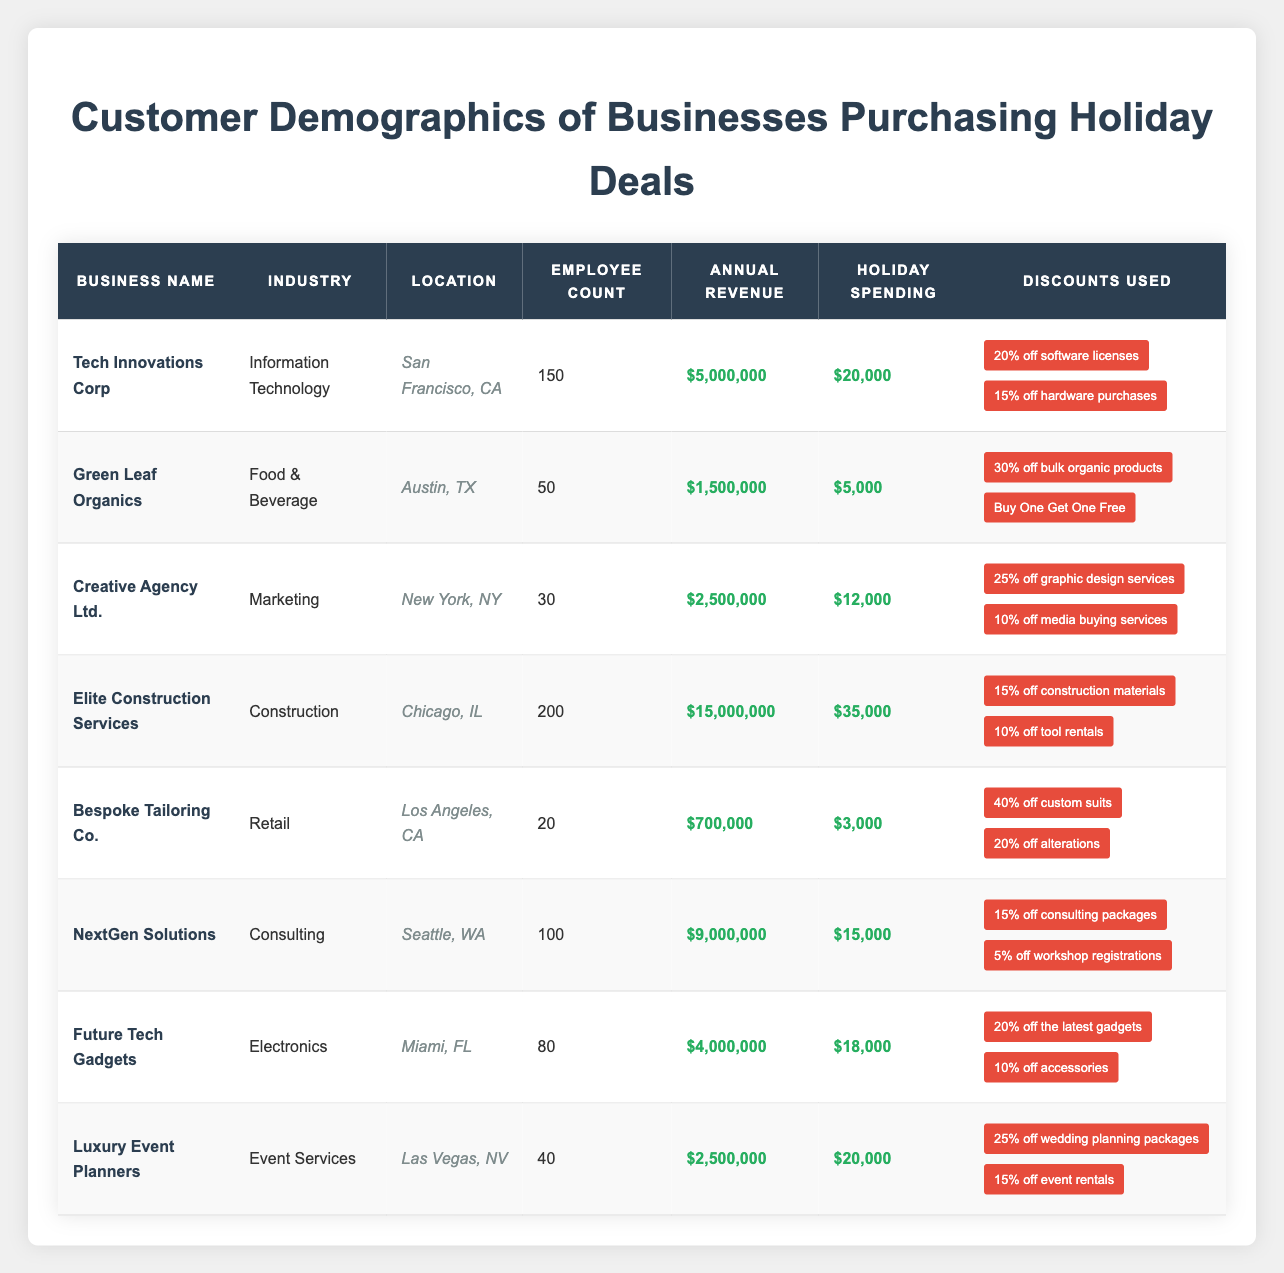What is the business with the highest holiday spending? Looking through the holiday spending amounts, Elite Construction Services shows $35,000, which is greater than all other businesses' holiday spending levels.
Answer: Elite Construction Services How many employees does Creative Agency Ltd. have? Referring to the employee count column, Creative Agency Ltd. has 30 employees listed.
Answer: 30 What is the total annual revenue of businesses located in California? The businesses in California are Tech Innovations Corp ($5,000,000) and Bespoke Tailoring Co. ($700,000). Adding these gives a total of $5,700,000.
Answer: $5,700,000 Does Green Leaf Organics use discounts related to organic products? According to the table, Green Leaf Organics utilizes discounts such as 30% off bulk organic products, which confirms the use of discounts related to organic products.
Answer: Yes What is the average holiday spending of the businesses listed in the table? Calculating the total holiday spending: $20,000 + $5,000 + $12,000 + $35,000 + $3,000 + $15,000 + $18,000 + $20,000 = $128,000. There are 8 businesses, so the average is $128,000 / 8 = $16,000.
Answer: $16,000 Which industry has the lowest number of employees, and how many employees does it have? Looking at the employee counts, Bespoke Tailoring Co. has the lowest at 20 employees.
Answer: Retail, 20 What percentage of holiday spending does Elite Construction Services represent compared to the total holiday spending of all businesses? First, the total holiday spending is $128,000. Elite Construction Services has $35,000, so the percentage is ($35,000 / $128,000) * 100 = 27.34%.
Answer: 27.34% What discounts are used by Future Tech Gadgets? The discounts listed for Future Tech Gadgets include 20% off the latest gadgets and 10% off accessories.
Answer: 20% off the latest gadgets and 10% off accessories Which business is located in New York and what is its annual revenue? The table indicates that Creative Agency Ltd. is in New York and has an annual revenue of $2,500,000.
Answer: Creative Agency Ltd., $2,500,000 Is there a business in Miami that offers holiday deals? Future Tech Gadgets is the business located in Miami and it does offer holiday deals.
Answer: Yes 